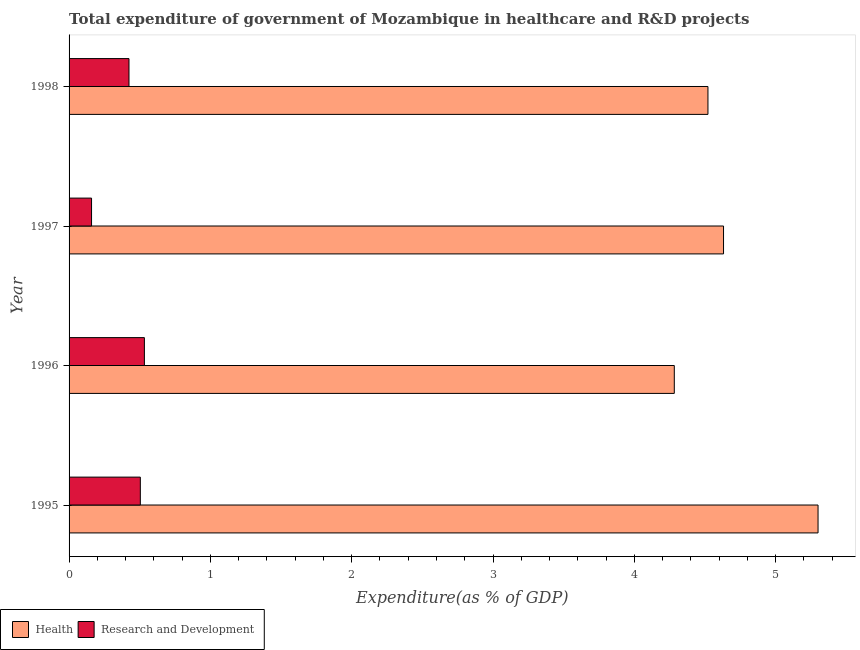How many different coloured bars are there?
Provide a short and direct response. 2. How many groups of bars are there?
Offer a very short reply. 4. How many bars are there on the 3rd tick from the top?
Keep it short and to the point. 2. How many bars are there on the 3rd tick from the bottom?
Offer a terse response. 2. What is the expenditure in r&d in 1996?
Make the answer very short. 0.53. Across all years, what is the maximum expenditure in r&d?
Provide a short and direct response. 0.53. Across all years, what is the minimum expenditure in healthcare?
Your answer should be very brief. 4.28. In which year was the expenditure in healthcare maximum?
Your response must be concise. 1995. What is the total expenditure in healthcare in the graph?
Keep it short and to the point. 18.73. What is the difference between the expenditure in r&d in 1995 and that in 1997?
Your answer should be very brief. 0.34. What is the difference between the expenditure in healthcare in 1995 and the expenditure in r&d in 1998?
Give a very brief answer. 4.88. What is the average expenditure in r&d per year?
Make the answer very short. 0.41. In the year 1996, what is the difference between the expenditure in r&d and expenditure in healthcare?
Provide a succinct answer. -3.75. What is the ratio of the expenditure in healthcare in 1995 to that in 1996?
Give a very brief answer. 1.24. Is the expenditure in r&d in 1996 less than that in 1997?
Keep it short and to the point. No. Is the difference between the expenditure in healthcare in 1995 and 1997 greater than the difference between the expenditure in r&d in 1995 and 1997?
Give a very brief answer. Yes. What is the difference between the highest and the second highest expenditure in healthcare?
Give a very brief answer. 0.67. What is the difference between the highest and the lowest expenditure in healthcare?
Give a very brief answer. 1.02. What does the 2nd bar from the top in 1998 represents?
Provide a succinct answer. Health. What does the 1st bar from the bottom in 1995 represents?
Ensure brevity in your answer.  Health. How many bars are there?
Make the answer very short. 8. How many years are there in the graph?
Offer a terse response. 4. Does the graph contain grids?
Make the answer very short. No. Where does the legend appear in the graph?
Ensure brevity in your answer.  Bottom left. How are the legend labels stacked?
Your response must be concise. Horizontal. What is the title of the graph?
Provide a short and direct response. Total expenditure of government of Mozambique in healthcare and R&D projects. What is the label or title of the X-axis?
Give a very brief answer. Expenditure(as % of GDP). What is the label or title of the Y-axis?
Provide a short and direct response. Year. What is the Expenditure(as % of GDP) in Health in 1995?
Your response must be concise. 5.3. What is the Expenditure(as % of GDP) of Research and Development in 1995?
Provide a succinct answer. 0.5. What is the Expenditure(as % of GDP) of Health in 1996?
Give a very brief answer. 4.28. What is the Expenditure(as % of GDP) of Research and Development in 1996?
Make the answer very short. 0.53. What is the Expenditure(as % of GDP) of Health in 1997?
Your answer should be compact. 4.63. What is the Expenditure(as % of GDP) of Research and Development in 1997?
Keep it short and to the point. 0.16. What is the Expenditure(as % of GDP) in Health in 1998?
Keep it short and to the point. 4.52. What is the Expenditure(as % of GDP) of Research and Development in 1998?
Your answer should be very brief. 0.42. Across all years, what is the maximum Expenditure(as % of GDP) of Health?
Your answer should be very brief. 5.3. Across all years, what is the maximum Expenditure(as % of GDP) in Research and Development?
Provide a succinct answer. 0.53. Across all years, what is the minimum Expenditure(as % of GDP) in Health?
Your answer should be very brief. 4.28. Across all years, what is the minimum Expenditure(as % of GDP) of Research and Development?
Give a very brief answer. 0.16. What is the total Expenditure(as % of GDP) of Health in the graph?
Make the answer very short. 18.73. What is the total Expenditure(as % of GDP) of Research and Development in the graph?
Offer a very short reply. 1.62. What is the difference between the Expenditure(as % of GDP) in Health in 1995 and that in 1996?
Provide a short and direct response. 1.02. What is the difference between the Expenditure(as % of GDP) in Research and Development in 1995 and that in 1996?
Keep it short and to the point. -0.03. What is the difference between the Expenditure(as % of GDP) in Health in 1995 and that in 1997?
Ensure brevity in your answer.  0.67. What is the difference between the Expenditure(as % of GDP) of Research and Development in 1995 and that in 1997?
Make the answer very short. 0.35. What is the difference between the Expenditure(as % of GDP) of Health in 1995 and that in 1998?
Offer a very short reply. 0.78. What is the difference between the Expenditure(as % of GDP) in Research and Development in 1995 and that in 1998?
Make the answer very short. 0.08. What is the difference between the Expenditure(as % of GDP) in Health in 1996 and that in 1997?
Make the answer very short. -0.35. What is the difference between the Expenditure(as % of GDP) in Research and Development in 1996 and that in 1997?
Make the answer very short. 0.37. What is the difference between the Expenditure(as % of GDP) in Health in 1996 and that in 1998?
Give a very brief answer. -0.24. What is the difference between the Expenditure(as % of GDP) of Research and Development in 1996 and that in 1998?
Provide a succinct answer. 0.11. What is the difference between the Expenditure(as % of GDP) in Health in 1997 and that in 1998?
Give a very brief answer. 0.11. What is the difference between the Expenditure(as % of GDP) of Research and Development in 1997 and that in 1998?
Provide a succinct answer. -0.26. What is the difference between the Expenditure(as % of GDP) in Health in 1995 and the Expenditure(as % of GDP) in Research and Development in 1996?
Offer a terse response. 4.77. What is the difference between the Expenditure(as % of GDP) of Health in 1995 and the Expenditure(as % of GDP) of Research and Development in 1997?
Make the answer very short. 5.14. What is the difference between the Expenditure(as % of GDP) in Health in 1995 and the Expenditure(as % of GDP) in Research and Development in 1998?
Make the answer very short. 4.88. What is the difference between the Expenditure(as % of GDP) of Health in 1996 and the Expenditure(as % of GDP) of Research and Development in 1997?
Make the answer very short. 4.12. What is the difference between the Expenditure(as % of GDP) in Health in 1996 and the Expenditure(as % of GDP) in Research and Development in 1998?
Offer a very short reply. 3.86. What is the difference between the Expenditure(as % of GDP) of Health in 1997 and the Expenditure(as % of GDP) of Research and Development in 1998?
Provide a succinct answer. 4.21. What is the average Expenditure(as % of GDP) of Health per year?
Offer a terse response. 4.68. What is the average Expenditure(as % of GDP) in Research and Development per year?
Provide a succinct answer. 0.41. In the year 1995, what is the difference between the Expenditure(as % of GDP) of Health and Expenditure(as % of GDP) of Research and Development?
Your answer should be very brief. 4.8. In the year 1996, what is the difference between the Expenditure(as % of GDP) of Health and Expenditure(as % of GDP) of Research and Development?
Your answer should be compact. 3.75. In the year 1997, what is the difference between the Expenditure(as % of GDP) of Health and Expenditure(as % of GDP) of Research and Development?
Offer a very short reply. 4.47. In the year 1998, what is the difference between the Expenditure(as % of GDP) in Health and Expenditure(as % of GDP) in Research and Development?
Your answer should be very brief. 4.1. What is the ratio of the Expenditure(as % of GDP) in Health in 1995 to that in 1996?
Your answer should be compact. 1.24. What is the ratio of the Expenditure(as % of GDP) in Research and Development in 1995 to that in 1996?
Make the answer very short. 0.95. What is the ratio of the Expenditure(as % of GDP) of Health in 1995 to that in 1997?
Keep it short and to the point. 1.14. What is the ratio of the Expenditure(as % of GDP) in Research and Development in 1995 to that in 1997?
Ensure brevity in your answer.  3.17. What is the ratio of the Expenditure(as % of GDP) in Health in 1995 to that in 1998?
Your response must be concise. 1.17. What is the ratio of the Expenditure(as % of GDP) in Research and Development in 1995 to that in 1998?
Provide a short and direct response. 1.19. What is the ratio of the Expenditure(as % of GDP) of Health in 1996 to that in 1997?
Ensure brevity in your answer.  0.92. What is the ratio of the Expenditure(as % of GDP) of Research and Development in 1996 to that in 1997?
Give a very brief answer. 3.35. What is the ratio of the Expenditure(as % of GDP) of Health in 1996 to that in 1998?
Give a very brief answer. 0.95. What is the ratio of the Expenditure(as % of GDP) of Research and Development in 1996 to that in 1998?
Your answer should be compact. 1.26. What is the ratio of the Expenditure(as % of GDP) in Health in 1997 to that in 1998?
Offer a terse response. 1.02. What is the ratio of the Expenditure(as % of GDP) in Research and Development in 1997 to that in 1998?
Provide a short and direct response. 0.38. What is the difference between the highest and the second highest Expenditure(as % of GDP) in Health?
Your answer should be compact. 0.67. What is the difference between the highest and the second highest Expenditure(as % of GDP) in Research and Development?
Make the answer very short. 0.03. What is the difference between the highest and the lowest Expenditure(as % of GDP) of Health?
Keep it short and to the point. 1.02. What is the difference between the highest and the lowest Expenditure(as % of GDP) in Research and Development?
Your response must be concise. 0.37. 